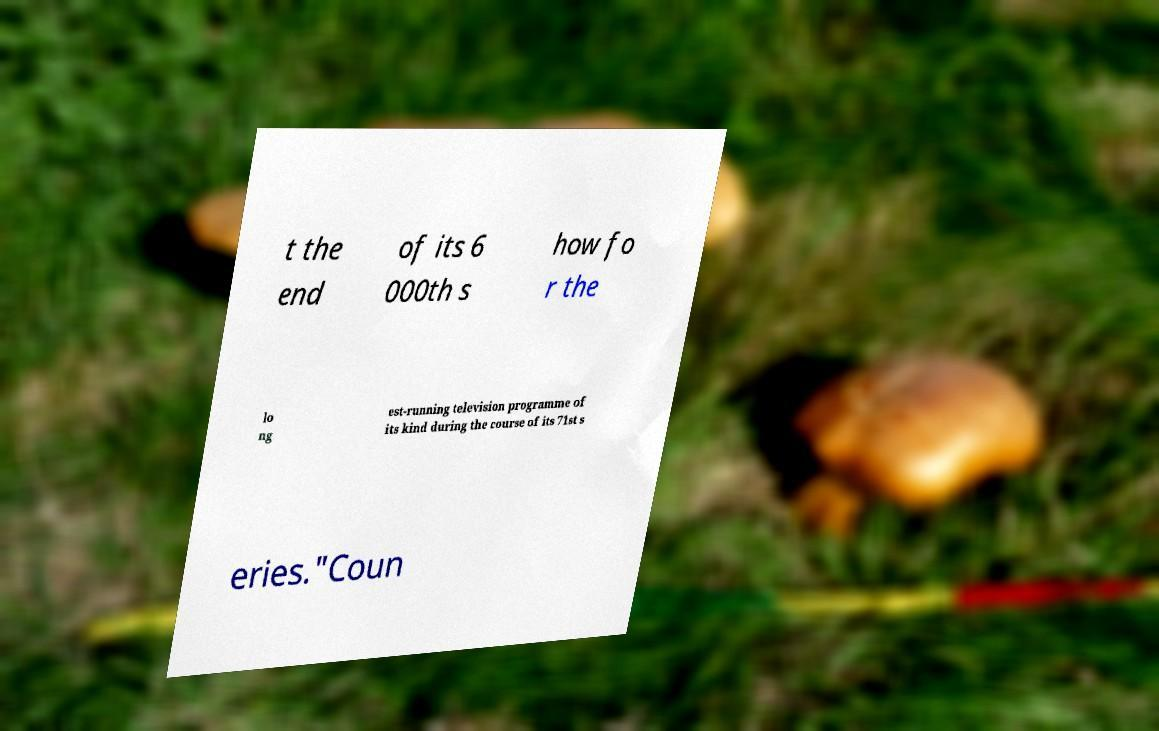Can you read and provide the text displayed in the image?This photo seems to have some interesting text. Can you extract and type it out for me? t the end of its 6 000th s how fo r the lo ng est-running television programme of its kind during the course of its 71st s eries."Coun 